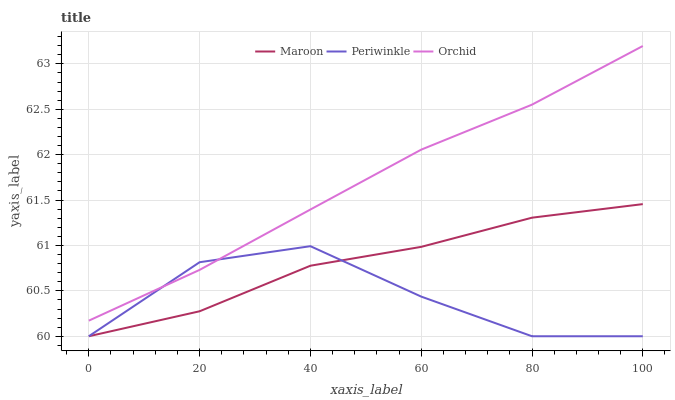Does Periwinkle have the minimum area under the curve?
Answer yes or no. Yes. Does Orchid have the maximum area under the curve?
Answer yes or no. Yes. Does Maroon have the minimum area under the curve?
Answer yes or no. No. Does Maroon have the maximum area under the curve?
Answer yes or no. No. Is Orchid the smoothest?
Answer yes or no. Yes. Is Periwinkle the roughest?
Answer yes or no. Yes. Is Maroon the smoothest?
Answer yes or no. No. Is Maroon the roughest?
Answer yes or no. No. Does Periwinkle have the lowest value?
Answer yes or no. Yes. Does Orchid have the lowest value?
Answer yes or no. No. Does Orchid have the highest value?
Answer yes or no. Yes. Does Maroon have the highest value?
Answer yes or no. No. Is Maroon less than Orchid?
Answer yes or no. Yes. Is Orchid greater than Maroon?
Answer yes or no. Yes. Does Periwinkle intersect Orchid?
Answer yes or no. Yes. Is Periwinkle less than Orchid?
Answer yes or no. No. Is Periwinkle greater than Orchid?
Answer yes or no. No. Does Maroon intersect Orchid?
Answer yes or no. No. 